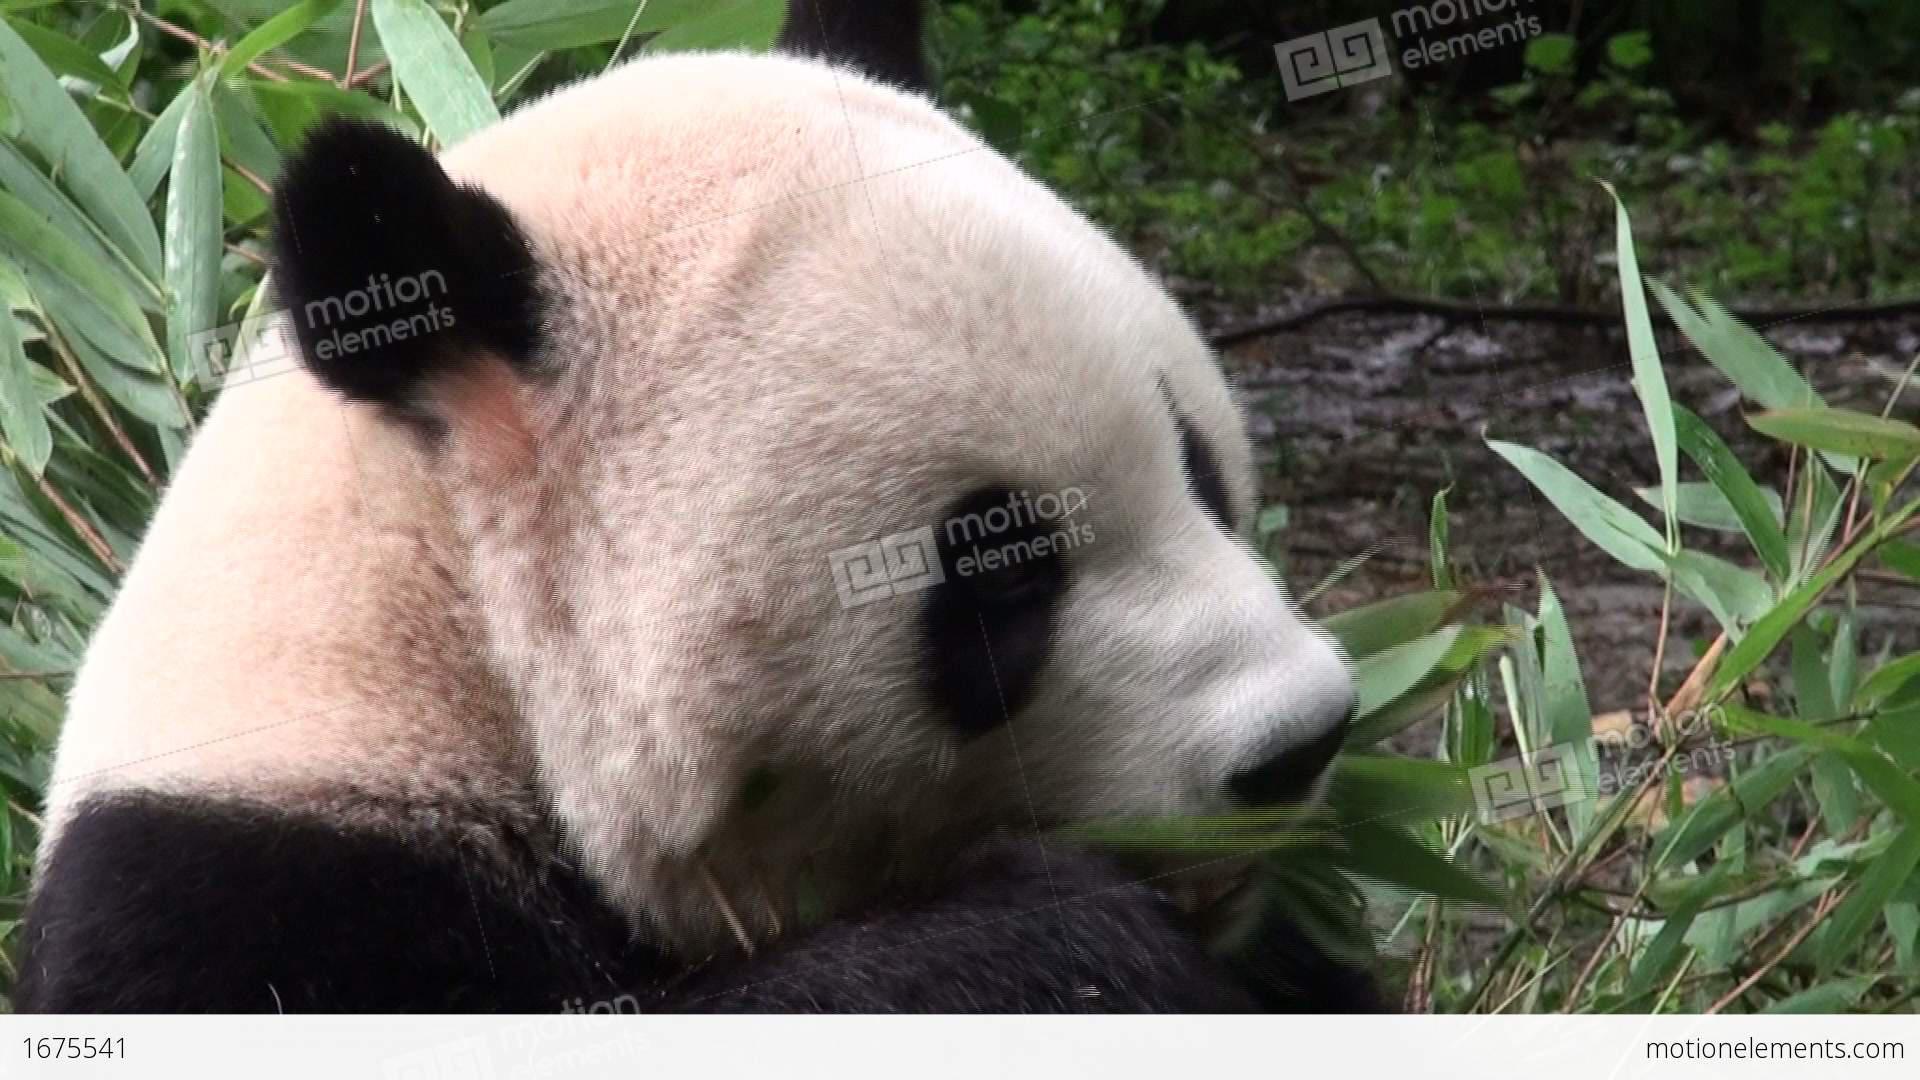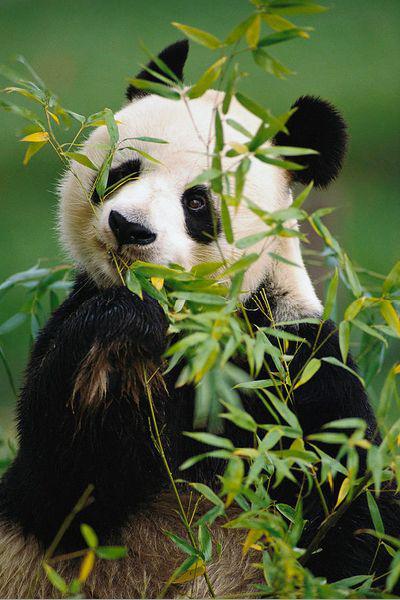The first image is the image on the left, the second image is the image on the right. Considering the images on both sides, is "Each image shows one forward-facing panda munching something, but the panda on the left is munching green leaves, while the panda on the right is munching yellow stalks." valid? Answer yes or no. No. 